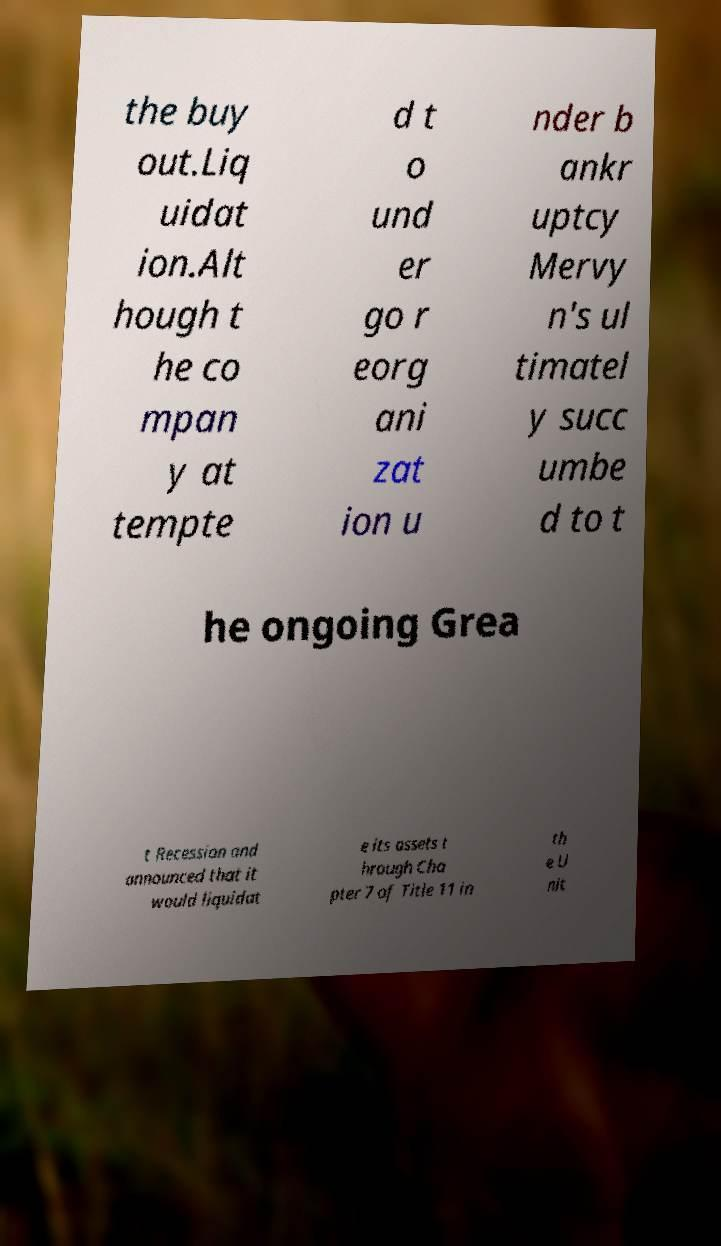Could you assist in decoding the text presented in this image and type it out clearly? the buy out.Liq uidat ion.Alt hough t he co mpan y at tempte d t o und er go r eorg ani zat ion u nder b ankr uptcy Mervy n's ul timatel y succ umbe d to t he ongoing Grea t Recession and announced that it would liquidat e its assets t hrough Cha pter 7 of Title 11 in th e U nit 